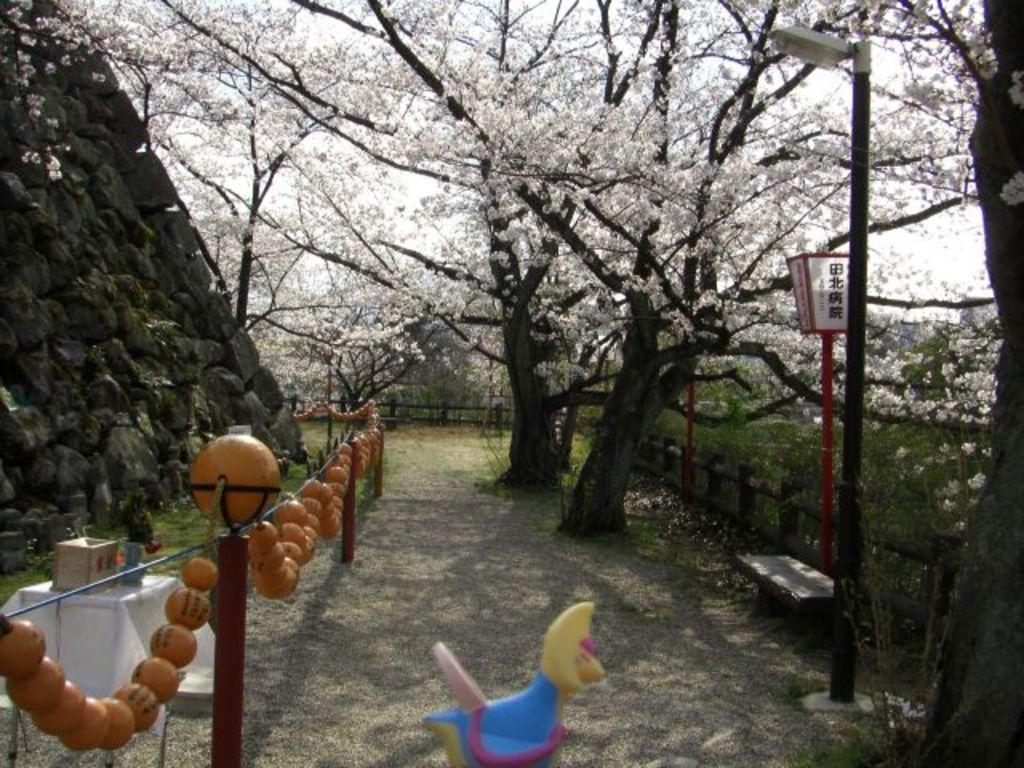How would you summarize this image in a sentence or two? In this image I see the path, poles on which there is decoration and I see a table over here on which there are few things and I see a toy over here and I see a bench. In the background I see the trees on which there are white flowers and I see few poles. I can also see the stones over here. 